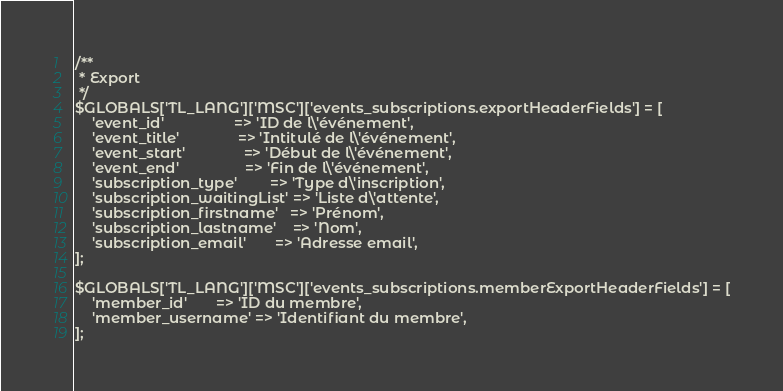Convert code to text. <code><loc_0><loc_0><loc_500><loc_500><_PHP_>
/**
 * Export
 */
$GLOBALS['TL_LANG']['MSC']['events_subscriptions.exportHeaderFields'] = [
    'event_id'                 => 'ID de l\'événement',
    'event_title'              => 'Intitulé de l\'événement',
    'event_start'              => 'Début de l\'événement',
    'event_end'                => 'Fin de l\'événement',
    'subscription_type'        => 'Type d\'inscription',
    'subscription_waitingList' => 'Liste d\'attente',
    'subscription_firstname'   => 'Prénom',
    'subscription_lastname'    => 'Nom',
    'subscription_email'       => 'Adresse email',
];

$GLOBALS['TL_LANG']['MSC']['events_subscriptions.memberExportHeaderFields'] = [
    'member_id'       => 'ID du membre',
    'member_username' => 'Identifiant du membre',
];
</code> 